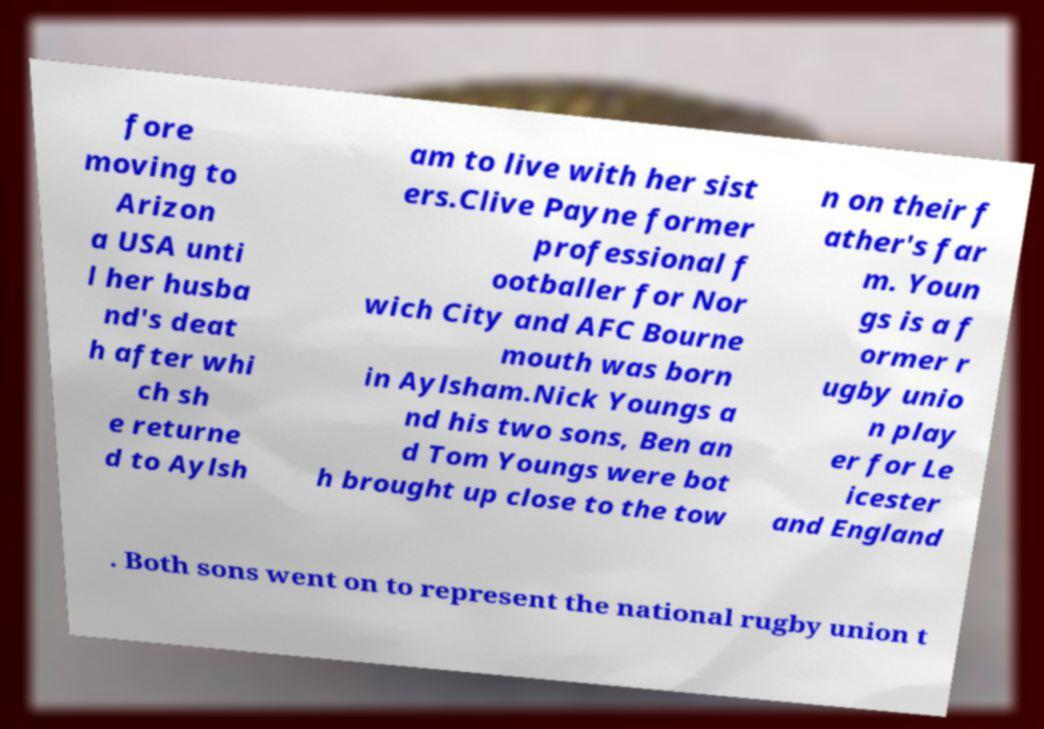What messages or text are displayed in this image? I need them in a readable, typed format. fore moving to Arizon a USA unti l her husba nd's deat h after whi ch sh e returne d to Aylsh am to live with her sist ers.Clive Payne former professional f ootballer for Nor wich City and AFC Bourne mouth was born in Aylsham.Nick Youngs a nd his two sons, Ben an d Tom Youngs were bot h brought up close to the tow n on their f ather's far m. Youn gs is a f ormer r ugby unio n play er for Le icester and England . Both sons went on to represent the national rugby union t 